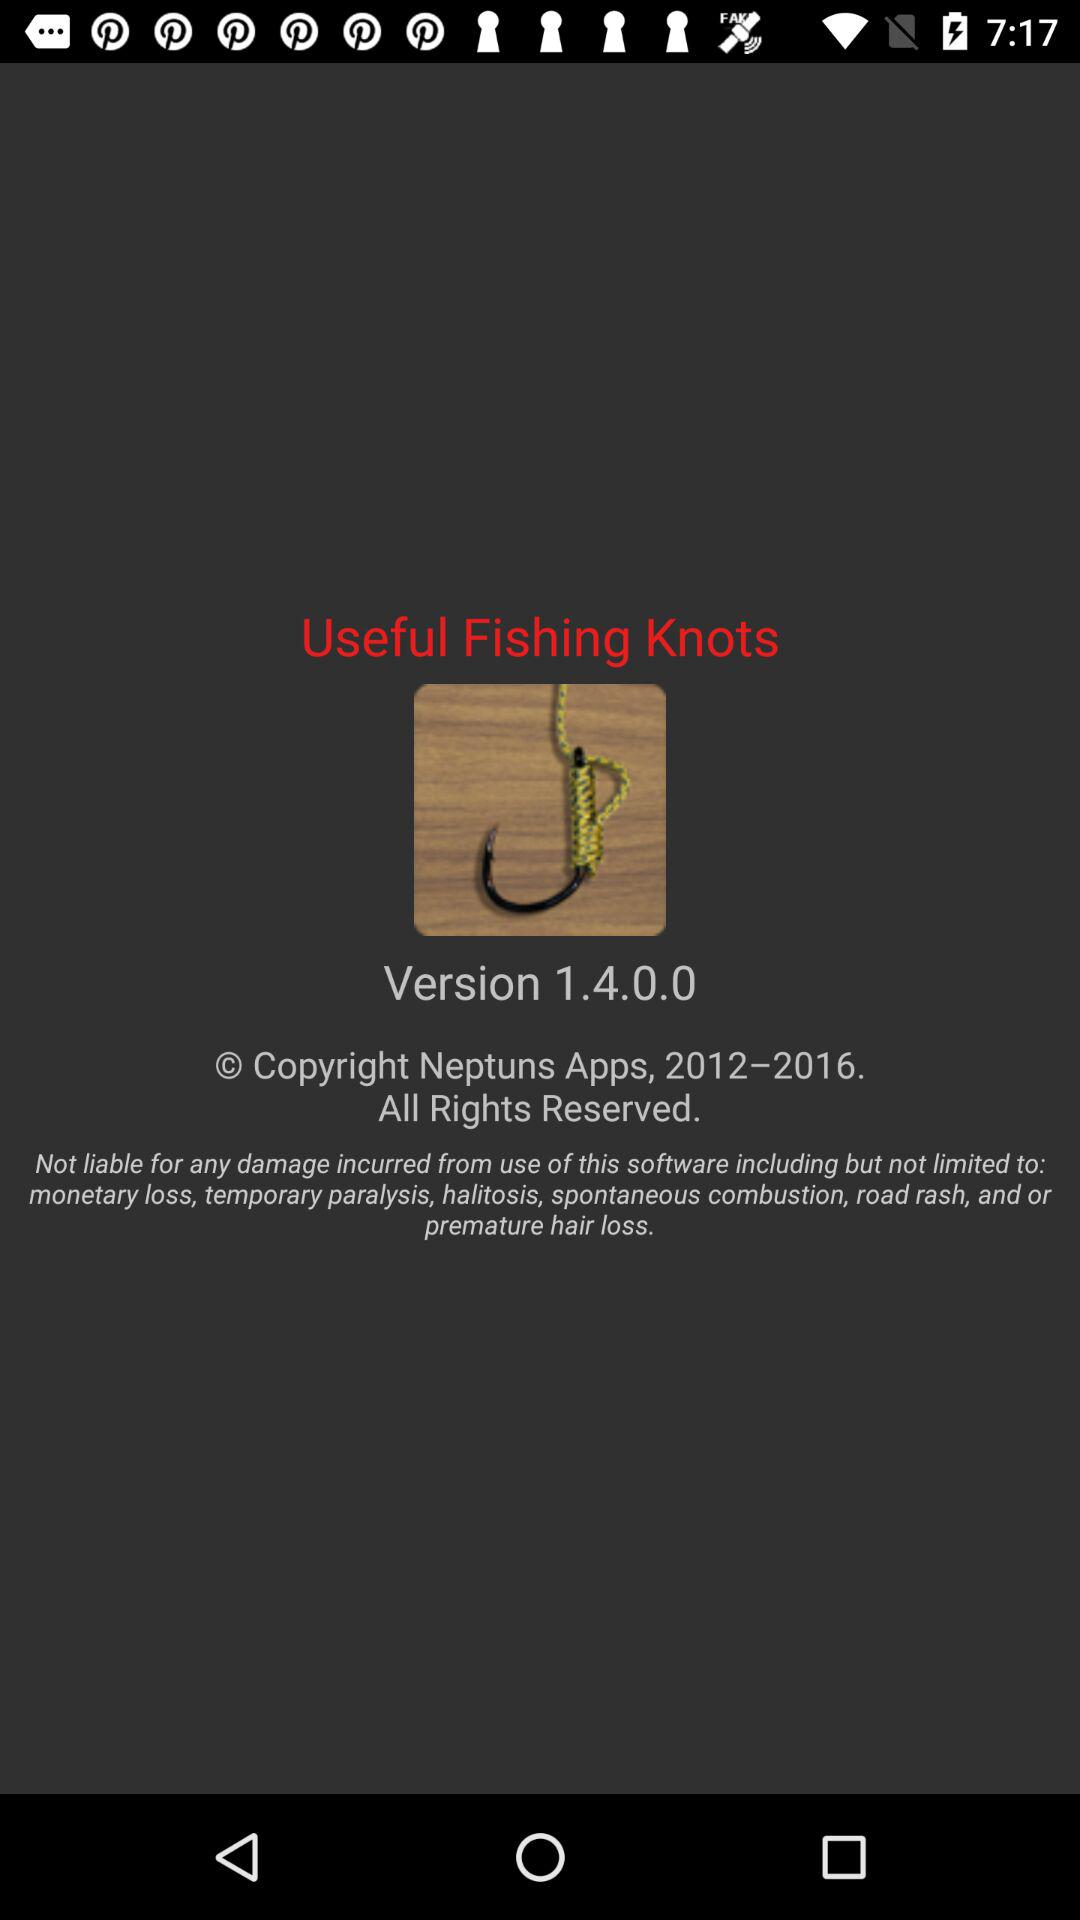How many useful fishing knots are there?
When the provided information is insufficient, respond with <no answer>. <no answer> 